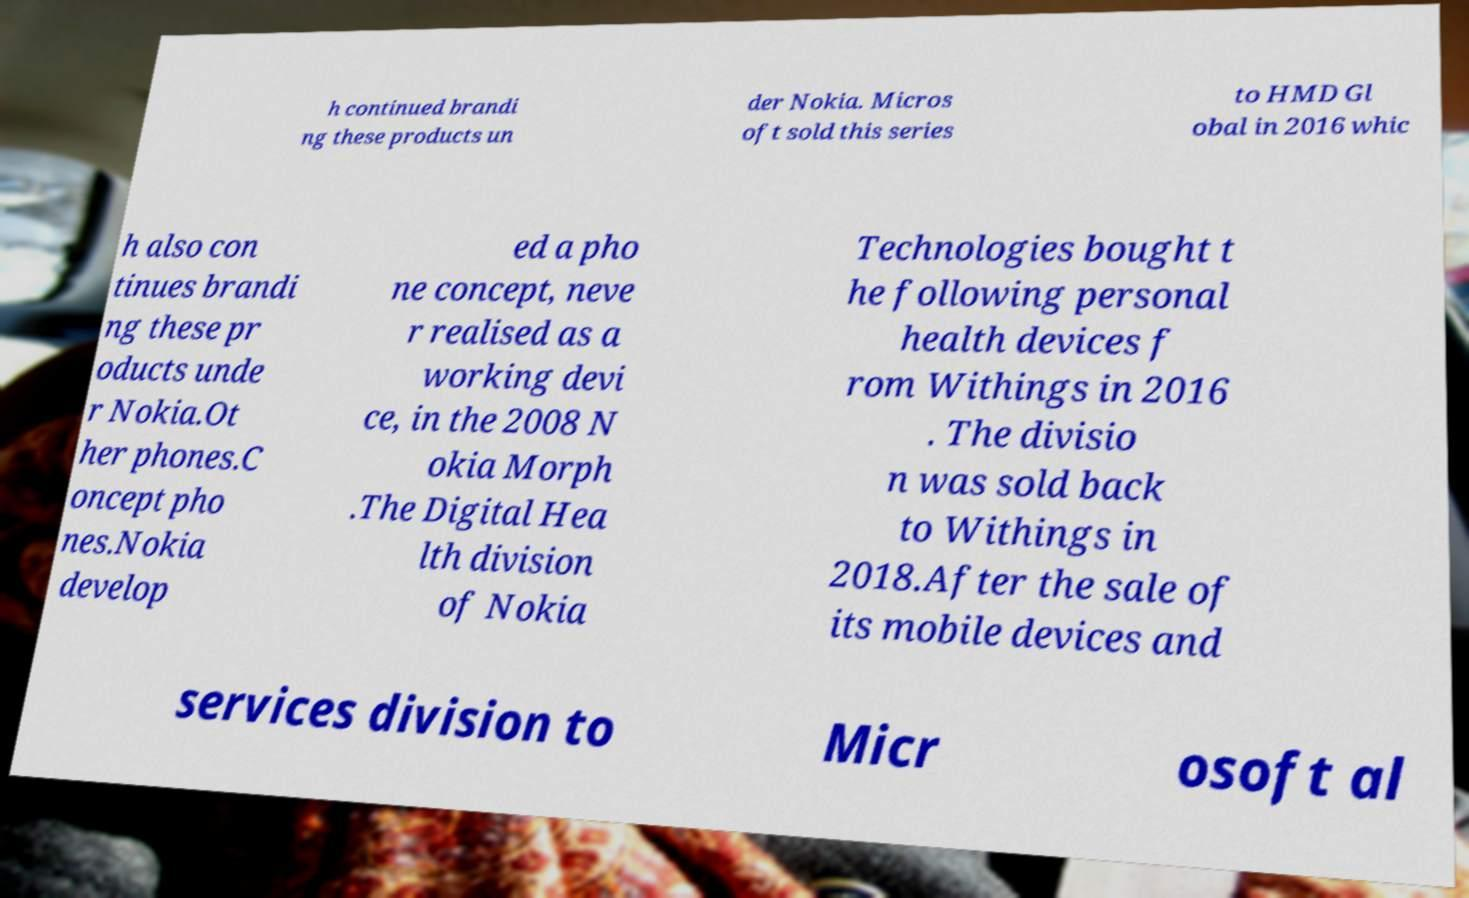What messages or text are displayed in this image? I need them in a readable, typed format. h continued brandi ng these products un der Nokia. Micros oft sold this series to HMD Gl obal in 2016 whic h also con tinues brandi ng these pr oducts unde r Nokia.Ot her phones.C oncept pho nes.Nokia develop ed a pho ne concept, neve r realised as a working devi ce, in the 2008 N okia Morph .The Digital Hea lth division of Nokia Technologies bought t he following personal health devices f rom Withings in 2016 . The divisio n was sold back to Withings in 2018.After the sale of its mobile devices and services division to Micr osoft al 